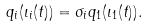Convert formula to latex. <formula><loc_0><loc_0><loc_500><loc_500>q _ { i } ( \iota _ { i } ( t ) ) = \sigma _ { i } q _ { 1 } ( \iota _ { 1 } ( t ) ) .</formula> 